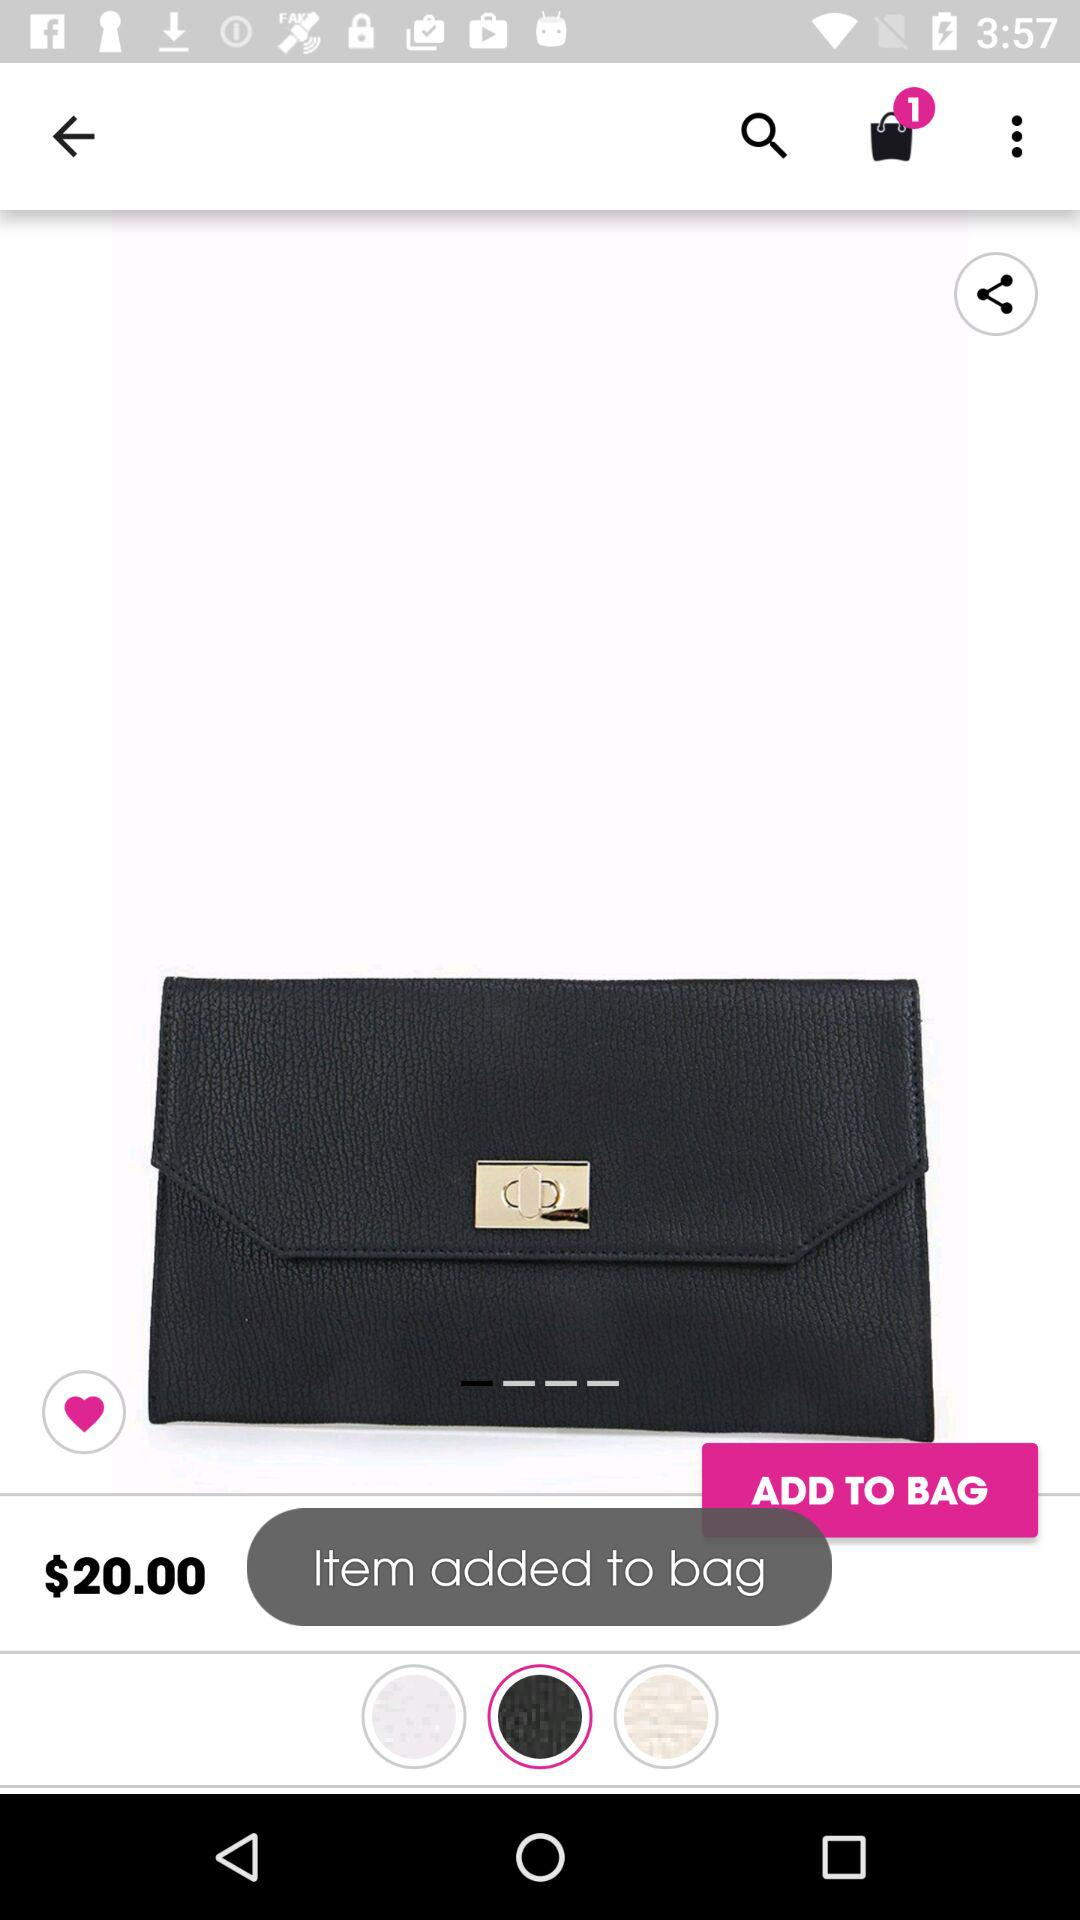How many items are in the bag? There is 1 item in the bag. 